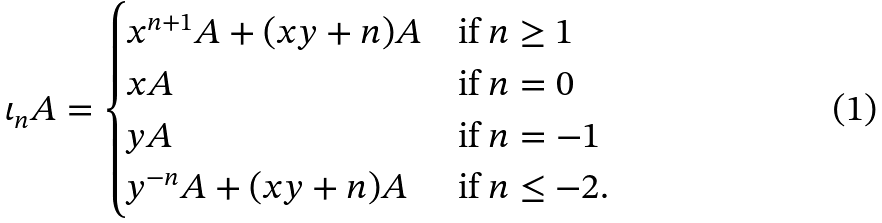<formula> <loc_0><loc_0><loc_500><loc_500>\iota _ { n } A = \begin{cases} x ^ { n + 1 } A + ( x y + n ) A & \text {if $n \geq 1$} \\ x A & \text {if $n = 0$} \\ y A & \text {if $n = -1$} \\ y ^ { - n } A + ( x y + n ) A & \text {if $n \leq -2 $} . \end{cases}</formula> 